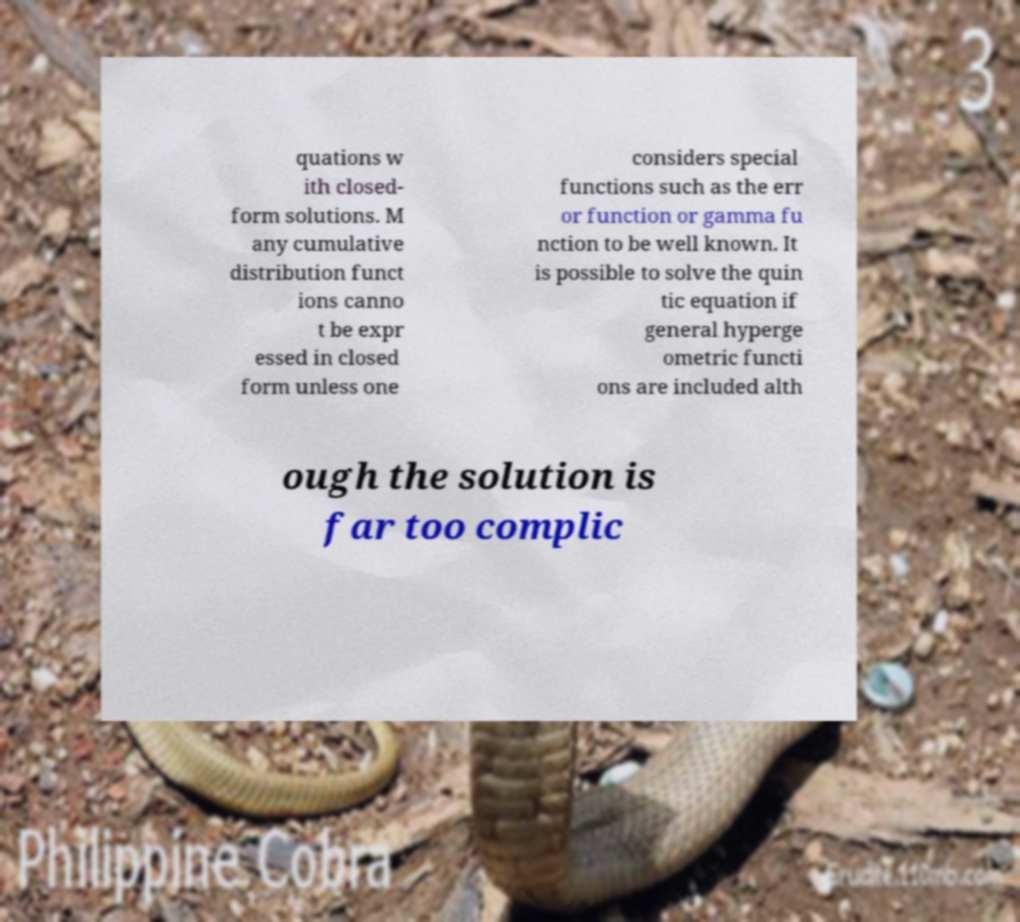Can you accurately transcribe the text from the provided image for me? quations w ith closed- form solutions. M any cumulative distribution funct ions canno t be expr essed in closed form unless one considers special functions such as the err or function or gamma fu nction to be well known. It is possible to solve the quin tic equation if general hyperge ometric functi ons are included alth ough the solution is far too complic 